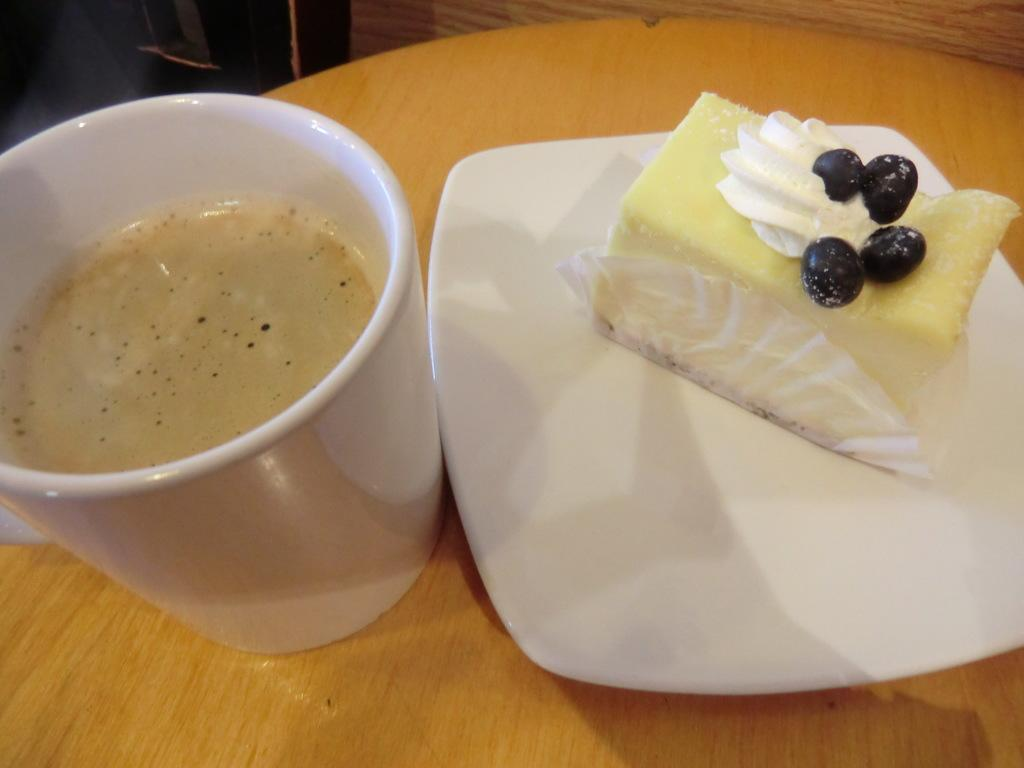What is in the cup that is visible in the image? There is a cup of coffee in the image. What is on the plate that is visible in the image? There is a piece of cake on a plate in the image. Where are the cup of coffee and the plate with cake located in the image? The cup of coffee and the plate with cake are placed on a wooden table. What type of polish is being applied to the wooden table in the image? There is no indication in the image that any polish is being applied to the wooden table. 